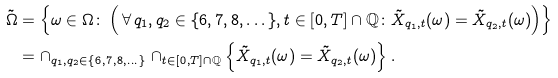Convert formula to latex. <formula><loc_0><loc_0><loc_500><loc_500>\tilde { \Omega } & = \left \{ \omega \in \Omega \colon \left ( \, \forall \, q _ { 1 } , q _ { 2 } \in \{ 6 , 7 , 8 , \dots \} , t \in [ 0 , T ] \cap \mathbb { Q } \colon \tilde { X } _ { q _ { 1 } , t } ( \omega ) = \tilde { X } _ { q _ { 2 } , t } ( \omega ) \right ) \right \} \\ & = \cap _ { q _ { 1 } , q _ { 2 } \in \{ 6 , 7 , 8 , \dots \} } \cap _ { t \in [ 0 , T ] \cap \mathbb { Q } } \left \{ \tilde { X } _ { q _ { 1 } , t } ( \omega ) = \tilde { X } _ { q _ { 2 } , t } ( \omega ) \right \} .</formula> 